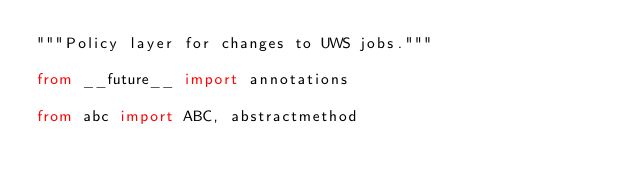Convert code to text. <code><loc_0><loc_0><loc_500><loc_500><_Python_>"""Policy layer for changes to UWS jobs."""

from __future__ import annotations

from abc import ABC, abstractmethod</code> 